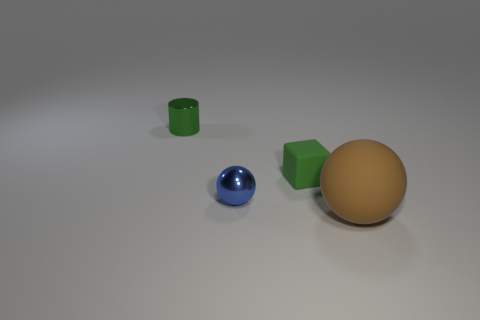There is a small thing that is left of the tiny blue metallic thing; does it have the same shape as the green matte object right of the tiny metal sphere?
Ensure brevity in your answer.  No. There is a thing that is both behind the blue thing and on the right side of the green metal object; what is its color?
Provide a short and direct response. Green. There is a green thing that is behind the small rubber thing; does it have the same size as the rubber block in front of the tiny cylinder?
Your response must be concise. Yes. What number of small objects have the same color as the small shiny cylinder?
Your answer should be very brief. 1. What number of small things are green matte blocks or red spheres?
Your answer should be very brief. 1. Is the small green thing that is to the right of the small green metallic object made of the same material as the large brown sphere?
Your answer should be very brief. Yes. There is a ball that is behind the brown ball; what is its color?
Offer a very short reply. Blue. Is there a matte ball of the same size as the green matte cube?
Make the answer very short. No. What material is the block that is the same size as the blue object?
Offer a terse response. Rubber. There is a blue metal sphere; does it have the same size as the green object in front of the tiny shiny cylinder?
Provide a succinct answer. Yes. 